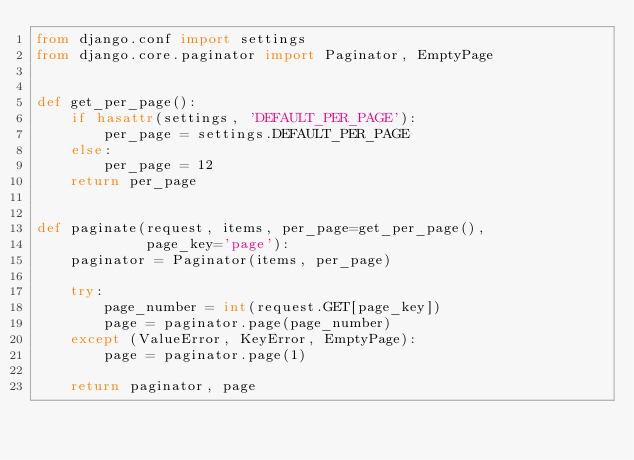<code> <loc_0><loc_0><loc_500><loc_500><_Python_>from django.conf import settings
from django.core.paginator import Paginator, EmptyPage


def get_per_page():
    if hasattr(settings, 'DEFAULT_PER_PAGE'):
        per_page = settings.DEFAULT_PER_PAGE
    else:
        per_page = 12
    return per_page


def paginate(request, items, per_page=get_per_page(),
             page_key='page'):
    paginator = Paginator(items, per_page)

    try:
        page_number = int(request.GET[page_key])
        page = paginator.page(page_number)
    except (ValueError, KeyError, EmptyPage):
        page = paginator.page(1)

    return paginator, page
</code> 